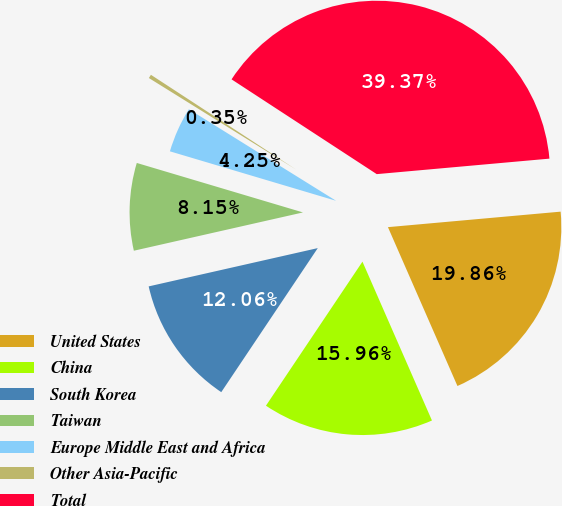Convert chart to OTSL. <chart><loc_0><loc_0><loc_500><loc_500><pie_chart><fcel>United States<fcel>China<fcel>South Korea<fcel>Taiwan<fcel>Europe Middle East and Africa<fcel>Other Asia-Pacific<fcel>Total<nl><fcel>19.86%<fcel>15.96%<fcel>12.06%<fcel>8.15%<fcel>4.25%<fcel>0.35%<fcel>39.37%<nl></chart> 